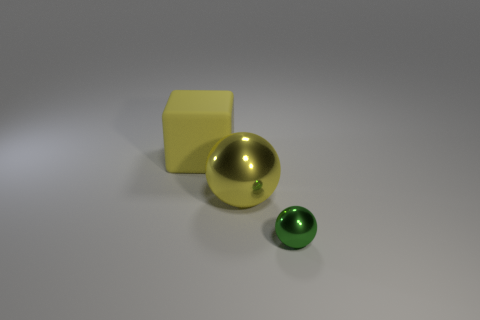Are there any other things that are made of the same material as the big cube?
Your response must be concise. No. There is a small thing; how many yellow rubber objects are on the right side of it?
Give a very brief answer. 0. What is the size of the other green thing that is the same shape as the large metallic object?
Give a very brief answer. Small. How many cyan things are either big metallic objects or big things?
Your answer should be very brief. 0. How many big things are behind the big yellow object in front of the large yellow rubber block?
Offer a very short reply. 1. How many other objects are the same shape as the large metal thing?
Provide a short and direct response. 1. There is another large thing that is the same color as the matte object; what material is it?
Keep it short and to the point. Metal. How many large matte objects have the same color as the cube?
Make the answer very short. 0. What is the color of the other ball that is the same material as the tiny green sphere?
Provide a succinct answer. Yellow. Is there a green ball of the same size as the rubber thing?
Provide a succinct answer. No. 